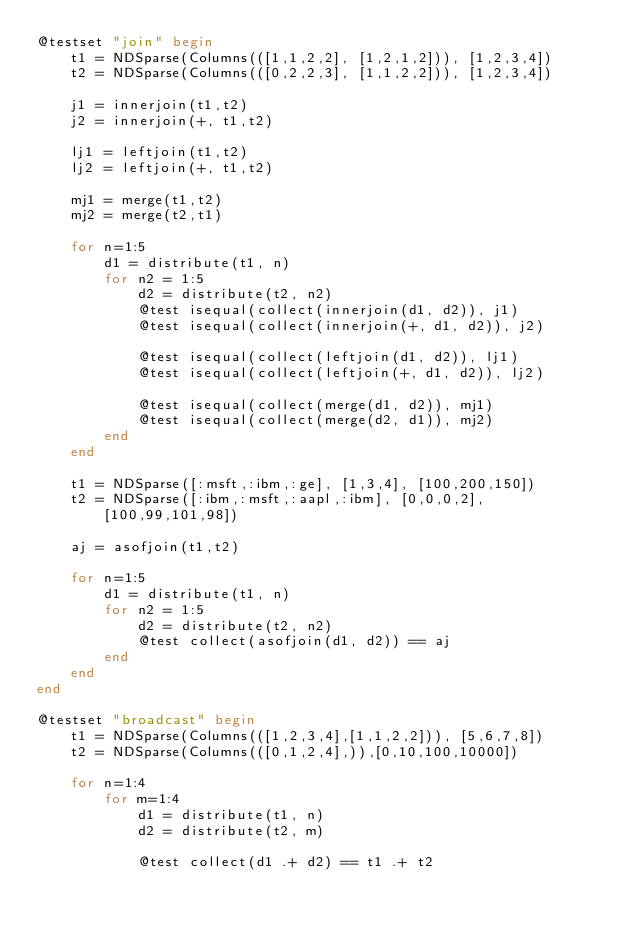<code> <loc_0><loc_0><loc_500><loc_500><_Julia_>@testset "join" begin
    t1 = NDSparse(Columns(([1,1,2,2], [1,2,1,2])), [1,2,3,4])
    t2 = NDSparse(Columns(([0,2,2,3], [1,1,2,2])), [1,2,3,4])

    j1 = innerjoin(t1,t2)
    j2 = innerjoin(+, t1,t2)

    lj1 = leftjoin(t1,t2)
    lj2 = leftjoin(+, t1,t2)

    mj1 = merge(t1,t2)
    mj2 = merge(t2,t1)

    for n=1:5
        d1 = distribute(t1, n)
        for n2 = 1:5
            d2 = distribute(t2, n2)
            @test isequal(collect(innerjoin(d1, d2)), j1)
            @test isequal(collect(innerjoin(+, d1, d2)), j2)

            @test isequal(collect(leftjoin(d1, d2)), lj1)
            @test isequal(collect(leftjoin(+, d1, d2)), lj2)

            @test isequal(collect(merge(d1, d2)), mj1)
            @test isequal(collect(merge(d2, d1)), mj2)
        end
    end

    t1 = NDSparse([:msft,:ibm,:ge], [1,3,4], [100,200,150])
    t2 = NDSparse([:ibm,:msft,:aapl,:ibm], [0,0,0,2], [100,99,101,98])

    aj = asofjoin(t1,t2)

    for n=1:5
        d1 = distribute(t1, n)
        for n2 = 1:5
            d2 = distribute(t2, n2)
            @test collect(asofjoin(d1, d2)) == aj
        end
    end
end

@testset "broadcast" begin
    t1 = NDSparse(Columns(([1,2,3,4],[1,1,2,2])), [5,6,7,8])
    t2 = NDSparse(Columns(([0,1,2,4],)),[0,10,100,10000])

    for n=1:4
        for m=1:4
            d1 = distribute(t1, n)
            d2 = distribute(t2, m)

            @test collect(d1 .+ d2) == t1 .+ t2</code> 